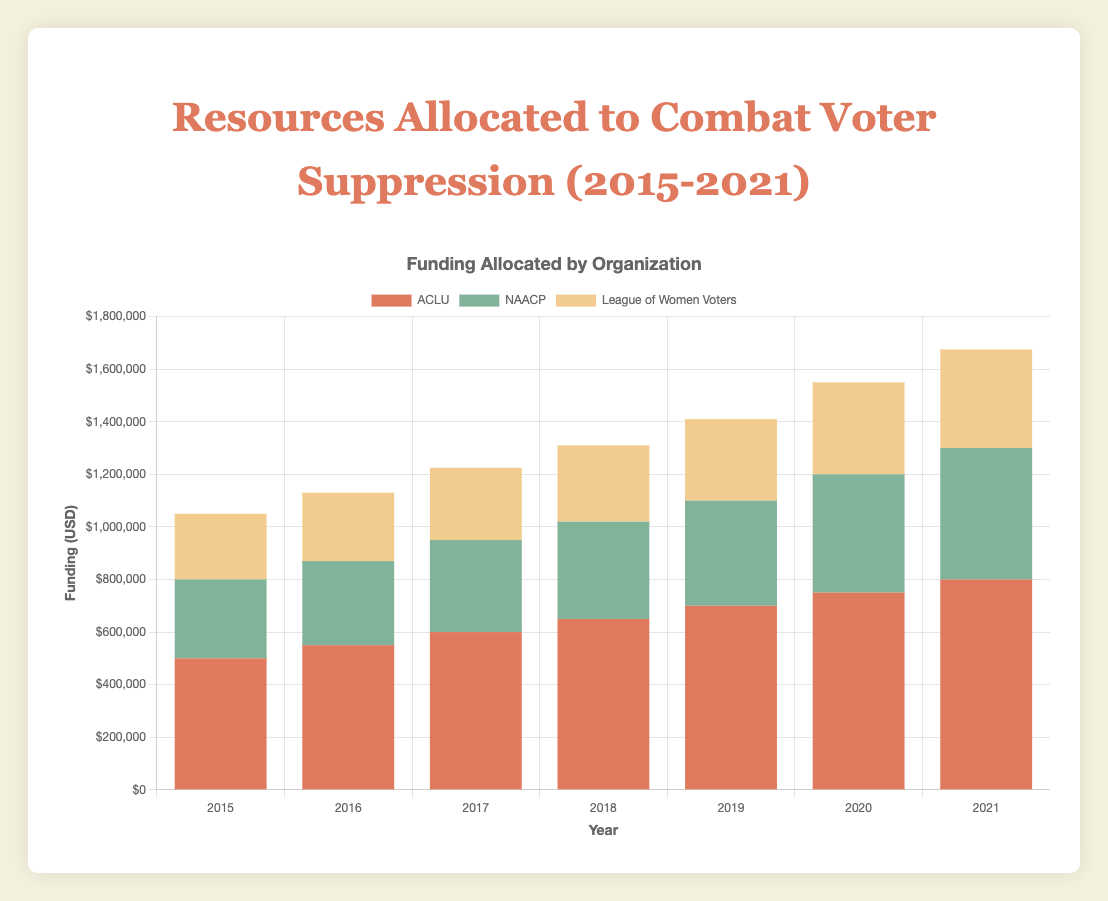What is the total funding allocated by all three organizations in 2021? Add up the funding amounts for ACLU, NAACP, and League of Women Voters for the year 2021. ACLU: $800,000, NAACP: $500,000, League of Women Voters: $375,000. Total funding = $800,000 + $500,000 + $375,000 = $1,675,000
Answer: $1,675,000 Which organization received the highest funding every year from 2015 to 2021? Examine each year's data to determine which organization received the most funding. For 2015 to 2021, ACLU consistently received the highest funding each year
Answer: ACLU How did the funding for the NAACP change from 2019 to 2020? Look at the funding for the NAACP in 2019 and in 2020. In 2019, the funding was $400,000, and in 2020 it was $450,000. The change is $450,000 - $400,000 = $50,000
Answer: Increased by $50,000 Compare the total community outreach events conducted by all organizations in 2017 versus 2021. Add the community outreach events for all organizations in 2017 and 2021. For 2017, ACLU: 25, NAACP: 15, League of Women Voters: 24. Total = 25 + 15 + 24 = 64. For 2021, ACLU: 45, NAACP: 25, League of Women Voters: 32. Total = 45 + 25 + 32 = 102
Answer: Increased by 38 events In which year did the League of Women Voters see the highest number of legal cases, and how many cases were there? Examine the number of legal cases for the League of Women Voters from 2015 to 2021. The highest number of legal cases was in 2021 with 16 cases
Answer: 2021, 16 cases What is the total amount of funding allocated by the NAACP from 2015 to 2021? Add up the yearly funding amounts for the NAACP from 2015 to 2021. Funding amounts: 2015: $300,000, 2016: $320,000, 2017: $350,000, 2018: $370,000, 2019: $400,000, 2020: $450,000, 2021: $500,000. Total = $300,000 + $320,000 + $350,000 + $370,000 + $400,000 + $450,000 + $500,000 = $2,690,000
Answer: $2,690,000 How many years did the League of Women Voters organize more community outreach events than the NAACP from 2015 to 2021? For each year from 2015-2021, compare the community outreach events of League of Women Voters to NAACP. For years 2015 (20 > 10), 2016 (22 > 12), 2017 (24 > 15), 2018 (25 > 18), 2019 (27 > 20), 2021 (32 > 25) the League of Women Voters had more events. So, there are 6 such years
Answer: 6 years What was the average number of training sessions conducted by the ACLU from 2015 to 2021? Add the number of training sessions conducted by ACLU from 2015 to 2021 and divide by the number of years. Training sessions: 2015: 25, 2016: 30, 2017: 35, 2018: 40, 2019: 45, 2020: 50, 2021: 55. Total = 25 + 30 + 35 + 40 + 45 + 50 + 55 = 280. Average = 280 / 7 = 40
Answer: 40 How many total training sessions did NAACP and League of Women Voters conduct in the year 2020? Add up the training sessions conducted by NAACP and League of Women Voters in 2020. NAACP: 35, League of Women Voters: 28. Total = 35 + 28 = 63
Answer: 63 sessions 